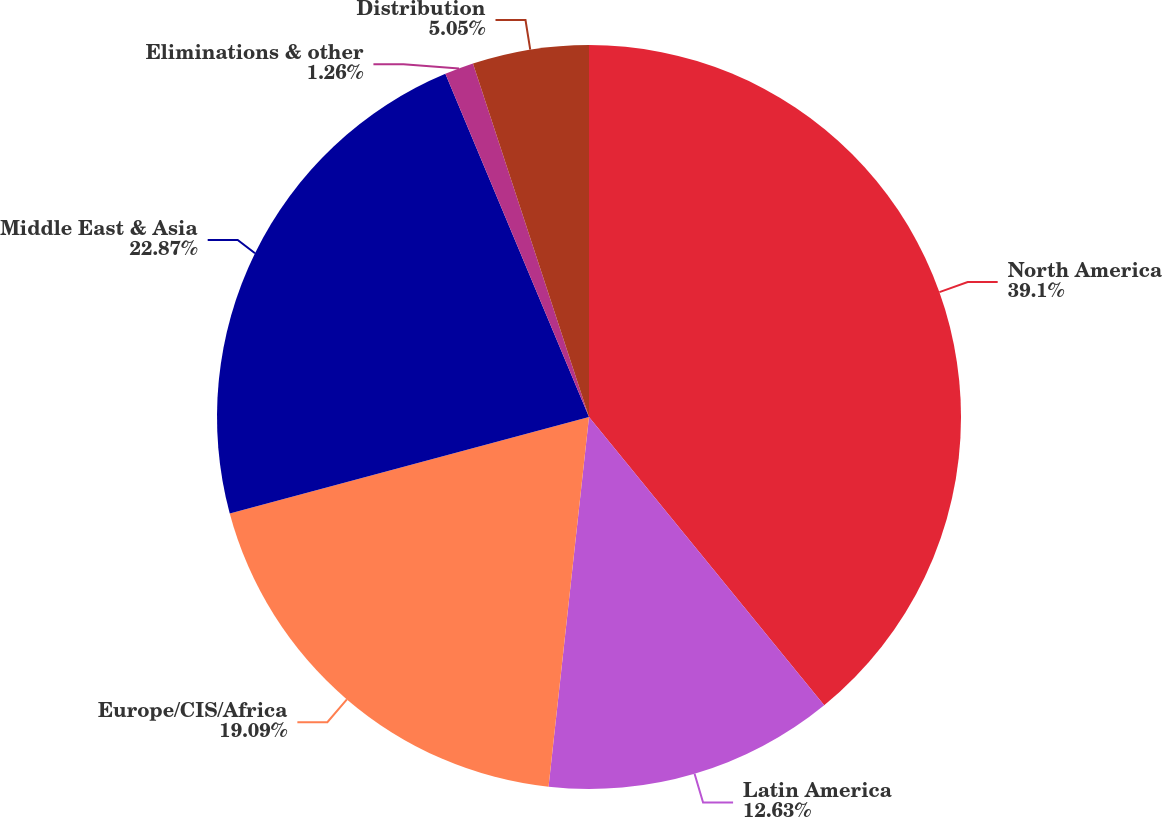Convert chart to OTSL. <chart><loc_0><loc_0><loc_500><loc_500><pie_chart><fcel>North America<fcel>Latin America<fcel>Europe/CIS/Africa<fcel>Middle East & Asia<fcel>Eliminations & other<fcel>Distribution<nl><fcel>39.11%<fcel>12.63%<fcel>19.09%<fcel>22.87%<fcel>1.26%<fcel>5.05%<nl></chart> 